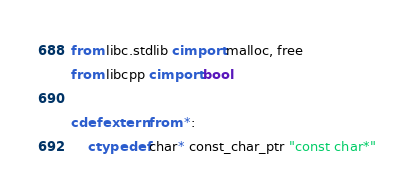<code> <loc_0><loc_0><loc_500><loc_500><_Cython_>from libc.stdlib cimport malloc, free
from libcpp cimport bool

cdef extern from *:
    ctypedef char* const_char_ptr "const char*"
</code> 